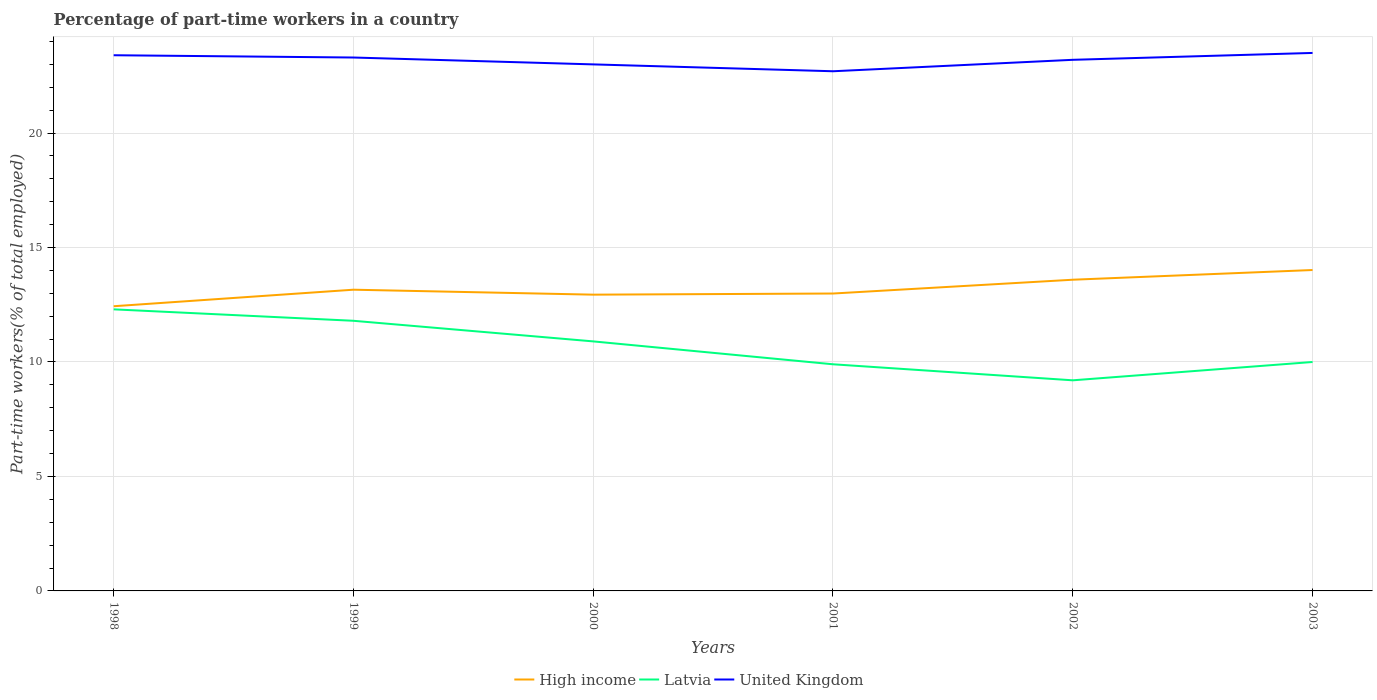Does the line corresponding to High income intersect with the line corresponding to United Kingdom?
Your answer should be compact. No. Is the number of lines equal to the number of legend labels?
Provide a short and direct response. Yes. Across all years, what is the maximum percentage of part-time workers in High income?
Provide a succinct answer. 12.44. In which year was the percentage of part-time workers in High income maximum?
Your answer should be very brief. 1998. What is the total percentage of part-time workers in High income in the graph?
Your answer should be compact. -0.56. What is the difference between the highest and the second highest percentage of part-time workers in High income?
Make the answer very short. 1.58. What is the difference between the highest and the lowest percentage of part-time workers in High income?
Your response must be concise. 2. Is the percentage of part-time workers in High income strictly greater than the percentage of part-time workers in United Kingdom over the years?
Your response must be concise. Yes. How many years are there in the graph?
Ensure brevity in your answer.  6. What is the difference between two consecutive major ticks on the Y-axis?
Keep it short and to the point. 5. Does the graph contain any zero values?
Your response must be concise. No. Where does the legend appear in the graph?
Offer a very short reply. Bottom center. How many legend labels are there?
Your response must be concise. 3. How are the legend labels stacked?
Make the answer very short. Horizontal. What is the title of the graph?
Offer a terse response. Percentage of part-time workers in a country. What is the label or title of the X-axis?
Provide a succinct answer. Years. What is the label or title of the Y-axis?
Ensure brevity in your answer.  Part-time workers(% of total employed). What is the Part-time workers(% of total employed) of High income in 1998?
Your answer should be compact. 12.44. What is the Part-time workers(% of total employed) of Latvia in 1998?
Provide a short and direct response. 12.3. What is the Part-time workers(% of total employed) of United Kingdom in 1998?
Your response must be concise. 23.4. What is the Part-time workers(% of total employed) in High income in 1999?
Provide a succinct answer. 13.16. What is the Part-time workers(% of total employed) in Latvia in 1999?
Your answer should be very brief. 11.8. What is the Part-time workers(% of total employed) of United Kingdom in 1999?
Provide a succinct answer. 23.3. What is the Part-time workers(% of total employed) in High income in 2000?
Your answer should be compact. 12.94. What is the Part-time workers(% of total employed) in Latvia in 2000?
Provide a succinct answer. 10.9. What is the Part-time workers(% of total employed) of United Kingdom in 2000?
Your answer should be compact. 23. What is the Part-time workers(% of total employed) of High income in 2001?
Make the answer very short. 12.99. What is the Part-time workers(% of total employed) in Latvia in 2001?
Provide a short and direct response. 9.9. What is the Part-time workers(% of total employed) of United Kingdom in 2001?
Keep it short and to the point. 22.7. What is the Part-time workers(% of total employed) in High income in 2002?
Your answer should be compact. 13.59. What is the Part-time workers(% of total employed) in Latvia in 2002?
Provide a succinct answer. 9.2. What is the Part-time workers(% of total employed) of United Kingdom in 2002?
Offer a very short reply. 23.2. What is the Part-time workers(% of total employed) of High income in 2003?
Offer a very short reply. 14.02. What is the Part-time workers(% of total employed) in United Kingdom in 2003?
Provide a short and direct response. 23.5. Across all years, what is the maximum Part-time workers(% of total employed) of High income?
Ensure brevity in your answer.  14.02. Across all years, what is the maximum Part-time workers(% of total employed) in Latvia?
Ensure brevity in your answer.  12.3. Across all years, what is the maximum Part-time workers(% of total employed) of United Kingdom?
Your answer should be very brief. 23.5. Across all years, what is the minimum Part-time workers(% of total employed) of High income?
Give a very brief answer. 12.44. Across all years, what is the minimum Part-time workers(% of total employed) of Latvia?
Make the answer very short. 9.2. Across all years, what is the minimum Part-time workers(% of total employed) of United Kingdom?
Your response must be concise. 22.7. What is the total Part-time workers(% of total employed) in High income in the graph?
Ensure brevity in your answer.  79.14. What is the total Part-time workers(% of total employed) in Latvia in the graph?
Make the answer very short. 64.1. What is the total Part-time workers(% of total employed) in United Kingdom in the graph?
Give a very brief answer. 139.1. What is the difference between the Part-time workers(% of total employed) of High income in 1998 and that in 1999?
Your response must be concise. -0.72. What is the difference between the Part-time workers(% of total employed) in Latvia in 1998 and that in 1999?
Keep it short and to the point. 0.5. What is the difference between the Part-time workers(% of total employed) in United Kingdom in 1998 and that in 1999?
Ensure brevity in your answer.  0.1. What is the difference between the Part-time workers(% of total employed) in High income in 1998 and that in 2000?
Make the answer very short. -0.51. What is the difference between the Part-time workers(% of total employed) in High income in 1998 and that in 2001?
Make the answer very short. -0.56. What is the difference between the Part-time workers(% of total employed) in United Kingdom in 1998 and that in 2001?
Provide a short and direct response. 0.7. What is the difference between the Part-time workers(% of total employed) of High income in 1998 and that in 2002?
Offer a very short reply. -1.16. What is the difference between the Part-time workers(% of total employed) in United Kingdom in 1998 and that in 2002?
Your answer should be compact. 0.2. What is the difference between the Part-time workers(% of total employed) in High income in 1998 and that in 2003?
Make the answer very short. -1.58. What is the difference between the Part-time workers(% of total employed) in Latvia in 1998 and that in 2003?
Your answer should be compact. 2.3. What is the difference between the Part-time workers(% of total employed) in High income in 1999 and that in 2000?
Ensure brevity in your answer.  0.22. What is the difference between the Part-time workers(% of total employed) in United Kingdom in 1999 and that in 2000?
Offer a terse response. 0.3. What is the difference between the Part-time workers(% of total employed) of High income in 1999 and that in 2001?
Give a very brief answer. 0.17. What is the difference between the Part-time workers(% of total employed) in Latvia in 1999 and that in 2001?
Keep it short and to the point. 1.9. What is the difference between the Part-time workers(% of total employed) in High income in 1999 and that in 2002?
Ensure brevity in your answer.  -0.44. What is the difference between the Part-time workers(% of total employed) in High income in 1999 and that in 2003?
Your response must be concise. -0.86. What is the difference between the Part-time workers(% of total employed) of Latvia in 1999 and that in 2003?
Offer a very short reply. 1.8. What is the difference between the Part-time workers(% of total employed) of High income in 2000 and that in 2001?
Make the answer very short. -0.05. What is the difference between the Part-time workers(% of total employed) of Latvia in 2000 and that in 2001?
Make the answer very short. 1. What is the difference between the Part-time workers(% of total employed) of United Kingdom in 2000 and that in 2001?
Your answer should be compact. 0.3. What is the difference between the Part-time workers(% of total employed) in High income in 2000 and that in 2002?
Your response must be concise. -0.65. What is the difference between the Part-time workers(% of total employed) in Latvia in 2000 and that in 2002?
Provide a short and direct response. 1.7. What is the difference between the Part-time workers(% of total employed) of High income in 2000 and that in 2003?
Give a very brief answer. -1.08. What is the difference between the Part-time workers(% of total employed) of United Kingdom in 2000 and that in 2003?
Your answer should be compact. -0.5. What is the difference between the Part-time workers(% of total employed) in High income in 2001 and that in 2002?
Provide a succinct answer. -0.6. What is the difference between the Part-time workers(% of total employed) in United Kingdom in 2001 and that in 2002?
Provide a short and direct response. -0.5. What is the difference between the Part-time workers(% of total employed) of High income in 2001 and that in 2003?
Offer a very short reply. -1.03. What is the difference between the Part-time workers(% of total employed) in Latvia in 2001 and that in 2003?
Your answer should be very brief. -0.1. What is the difference between the Part-time workers(% of total employed) in High income in 2002 and that in 2003?
Your answer should be very brief. -0.42. What is the difference between the Part-time workers(% of total employed) in United Kingdom in 2002 and that in 2003?
Provide a short and direct response. -0.3. What is the difference between the Part-time workers(% of total employed) in High income in 1998 and the Part-time workers(% of total employed) in Latvia in 1999?
Provide a succinct answer. 0.64. What is the difference between the Part-time workers(% of total employed) in High income in 1998 and the Part-time workers(% of total employed) in United Kingdom in 1999?
Provide a short and direct response. -10.86. What is the difference between the Part-time workers(% of total employed) of High income in 1998 and the Part-time workers(% of total employed) of Latvia in 2000?
Provide a succinct answer. 1.54. What is the difference between the Part-time workers(% of total employed) of High income in 1998 and the Part-time workers(% of total employed) of United Kingdom in 2000?
Keep it short and to the point. -10.56. What is the difference between the Part-time workers(% of total employed) in Latvia in 1998 and the Part-time workers(% of total employed) in United Kingdom in 2000?
Your answer should be compact. -10.7. What is the difference between the Part-time workers(% of total employed) in High income in 1998 and the Part-time workers(% of total employed) in Latvia in 2001?
Provide a succinct answer. 2.54. What is the difference between the Part-time workers(% of total employed) in High income in 1998 and the Part-time workers(% of total employed) in United Kingdom in 2001?
Provide a short and direct response. -10.26. What is the difference between the Part-time workers(% of total employed) of High income in 1998 and the Part-time workers(% of total employed) of Latvia in 2002?
Offer a very short reply. 3.24. What is the difference between the Part-time workers(% of total employed) in High income in 1998 and the Part-time workers(% of total employed) in United Kingdom in 2002?
Ensure brevity in your answer.  -10.76. What is the difference between the Part-time workers(% of total employed) in High income in 1998 and the Part-time workers(% of total employed) in Latvia in 2003?
Provide a short and direct response. 2.44. What is the difference between the Part-time workers(% of total employed) in High income in 1998 and the Part-time workers(% of total employed) in United Kingdom in 2003?
Offer a very short reply. -11.06. What is the difference between the Part-time workers(% of total employed) of High income in 1999 and the Part-time workers(% of total employed) of Latvia in 2000?
Ensure brevity in your answer.  2.26. What is the difference between the Part-time workers(% of total employed) of High income in 1999 and the Part-time workers(% of total employed) of United Kingdom in 2000?
Provide a short and direct response. -9.84. What is the difference between the Part-time workers(% of total employed) of High income in 1999 and the Part-time workers(% of total employed) of Latvia in 2001?
Offer a terse response. 3.26. What is the difference between the Part-time workers(% of total employed) of High income in 1999 and the Part-time workers(% of total employed) of United Kingdom in 2001?
Your response must be concise. -9.54. What is the difference between the Part-time workers(% of total employed) of High income in 1999 and the Part-time workers(% of total employed) of Latvia in 2002?
Provide a succinct answer. 3.96. What is the difference between the Part-time workers(% of total employed) of High income in 1999 and the Part-time workers(% of total employed) of United Kingdom in 2002?
Give a very brief answer. -10.04. What is the difference between the Part-time workers(% of total employed) of High income in 1999 and the Part-time workers(% of total employed) of Latvia in 2003?
Offer a terse response. 3.16. What is the difference between the Part-time workers(% of total employed) in High income in 1999 and the Part-time workers(% of total employed) in United Kingdom in 2003?
Keep it short and to the point. -10.34. What is the difference between the Part-time workers(% of total employed) of Latvia in 1999 and the Part-time workers(% of total employed) of United Kingdom in 2003?
Your answer should be compact. -11.7. What is the difference between the Part-time workers(% of total employed) in High income in 2000 and the Part-time workers(% of total employed) in Latvia in 2001?
Give a very brief answer. 3.04. What is the difference between the Part-time workers(% of total employed) of High income in 2000 and the Part-time workers(% of total employed) of United Kingdom in 2001?
Your answer should be compact. -9.76. What is the difference between the Part-time workers(% of total employed) in Latvia in 2000 and the Part-time workers(% of total employed) in United Kingdom in 2001?
Your answer should be very brief. -11.8. What is the difference between the Part-time workers(% of total employed) of High income in 2000 and the Part-time workers(% of total employed) of Latvia in 2002?
Your response must be concise. 3.74. What is the difference between the Part-time workers(% of total employed) of High income in 2000 and the Part-time workers(% of total employed) of United Kingdom in 2002?
Give a very brief answer. -10.26. What is the difference between the Part-time workers(% of total employed) of Latvia in 2000 and the Part-time workers(% of total employed) of United Kingdom in 2002?
Your answer should be compact. -12.3. What is the difference between the Part-time workers(% of total employed) in High income in 2000 and the Part-time workers(% of total employed) in Latvia in 2003?
Make the answer very short. 2.94. What is the difference between the Part-time workers(% of total employed) in High income in 2000 and the Part-time workers(% of total employed) in United Kingdom in 2003?
Keep it short and to the point. -10.56. What is the difference between the Part-time workers(% of total employed) of High income in 2001 and the Part-time workers(% of total employed) of Latvia in 2002?
Keep it short and to the point. 3.79. What is the difference between the Part-time workers(% of total employed) in High income in 2001 and the Part-time workers(% of total employed) in United Kingdom in 2002?
Your answer should be very brief. -10.21. What is the difference between the Part-time workers(% of total employed) in Latvia in 2001 and the Part-time workers(% of total employed) in United Kingdom in 2002?
Make the answer very short. -13.3. What is the difference between the Part-time workers(% of total employed) in High income in 2001 and the Part-time workers(% of total employed) in Latvia in 2003?
Provide a short and direct response. 2.99. What is the difference between the Part-time workers(% of total employed) in High income in 2001 and the Part-time workers(% of total employed) in United Kingdom in 2003?
Offer a very short reply. -10.51. What is the difference between the Part-time workers(% of total employed) of Latvia in 2001 and the Part-time workers(% of total employed) of United Kingdom in 2003?
Give a very brief answer. -13.6. What is the difference between the Part-time workers(% of total employed) of High income in 2002 and the Part-time workers(% of total employed) of Latvia in 2003?
Give a very brief answer. 3.59. What is the difference between the Part-time workers(% of total employed) of High income in 2002 and the Part-time workers(% of total employed) of United Kingdom in 2003?
Your answer should be compact. -9.91. What is the difference between the Part-time workers(% of total employed) of Latvia in 2002 and the Part-time workers(% of total employed) of United Kingdom in 2003?
Provide a succinct answer. -14.3. What is the average Part-time workers(% of total employed) of High income per year?
Offer a terse response. 13.19. What is the average Part-time workers(% of total employed) of Latvia per year?
Provide a succinct answer. 10.68. What is the average Part-time workers(% of total employed) of United Kingdom per year?
Your answer should be compact. 23.18. In the year 1998, what is the difference between the Part-time workers(% of total employed) of High income and Part-time workers(% of total employed) of Latvia?
Your response must be concise. 0.14. In the year 1998, what is the difference between the Part-time workers(% of total employed) in High income and Part-time workers(% of total employed) in United Kingdom?
Keep it short and to the point. -10.96. In the year 1999, what is the difference between the Part-time workers(% of total employed) of High income and Part-time workers(% of total employed) of Latvia?
Offer a terse response. 1.36. In the year 1999, what is the difference between the Part-time workers(% of total employed) in High income and Part-time workers(% of total employed) in United Kingdom?
Your response must be concise. -10.14. In the year 2000, what is the difference between the Part-time workers(% of total employed) in High income and Part-time workers(% of total employed) in Latvia?
Your answer should be very brief. 2.04. In the year 2000, what is the difference between the Part-time workers(% of total employed) in High income and Part-time workers(% of total employed) in United Kingdom?
Offer a very short reply. -10.06. In the year 2001, what is the difference between the Part-time workers(% of total employed) in High income and Part-time workers(% of total employed) in Latvia?
Provide a succinct answer. 3.09. In the year 2001, what is the difference between the Part-time workers(% of total employed) of High income and Part-time workers(% of total employed) of United Kingdom?
Your response must be concise. -9.71. In the year 2002, what is the difference between the Part-time workers(% of total employed) in High income and Part-time workers(% of total employed) in Latvia?
Make the answer very short. 4.39. In the year 2002, what is the difference between the Part-time workers(% of total employed) in High income and Part-time workers(% of total employed) in United Kingdom?
Your answer should be compact. -9.61. In the year 2002, what is the difference between the Part-time workers(% of total employed) in Latvia and Part-time workers(% of total employed) in United Kingdom?
Give a very brief answer. -14. In the year 2003, what is the difference between the Part-time workers(% of total employed) of High income and Part-time workers(% of total employed) of Latvia?
Your response must be concise. 4.02. In the year 2003, what is the difference between the Part-time workers(% of total employed) of High income and Part-time workers(% of total employed) of United Kingdom?
Provide a short and direct response. -9.48. What is the ratio of the Part-time workers(% of total employed) of High income in 1998 to that in 1999?
Ensure brevity in your answer.  0.95. What is the ratio of the Part-time workers(% of total employed) of Latvia in 1998 to that in 1999?
Offer a very short reply. 1.04. What is the ratio of the Part-time workers(% of total employed) of High income in 1998 to that in 2000?
Ensure brevity in your answer.  0.96. What is the ratio of the Part-time workers(% of total employed) of Latvia in 1998 to that in 2000?
Give a very brief answer. 1.13. What is the ratio of the Part-time workers(% of total employed) in United Kingdom in 1998 to that in 2000?
Make the answer very short. 1.02. What is the ratio of the Part-time workers(% of total employed) in High income in 1998 to that in 2001?
Keep it short and to the point. 0.96. What is the ratio of the Part-time workers(% of total employed) of Latvia in 1998 to that in 2001?
Provide a short and direct response. 1.24. What is the ratio of the Part-time workers(% of total employed) of United Kingdom in 1998 to that in 2001?
Your response must be concise. 1.03. What is the ratio of the Part-time workers(% of total employed) in High income in 1998 to that in 2002?
Offer a terse response. 0.91. What is the ratio of the Part-time workers(% of total employed) in Latvia in 1998 to that in 2002?
Give a very brief answer. 1.34. What is the ratio of the Part-time workers(% of total employed) in United Kingdom in 1998 to that in 2002?
Ensure brevity in your answer.  1.01. What is the ratio of the Part-time workers(% of total employed) in High income in 1998 to that in 2003?
Offer a very short reply. 0.89. What is the ratio of the Part-time workers(% of total employed) in Latvia in 1998 to that in 2003?
Keep it short and to the point. 1.23. What is the ratio of the Part-time workers(% of total employed) of United Kingdom in 1998 to that in 2003?
Make the answer very short. 1. What is the ratio of the Part-time workers(% of total employed) in High income in 1999 to that in 2000?
Keep it short and to the point. 1.02. What is the ratio of the Part-time workers(% of total employed) of Latvia in 1999 to that in 2000?
Offer a very short reply. 1.08. What is the ratio of the Part-time workers(% of total employed) in High income in 1999 to that in 2001?
Keep it short and to the point. 1.01. What is the ratio of the Part-time workers(% of total employed) of Latvia in 1999 to that in 2001?
Ensure brevity in your answer.  1.19. What is the ratio of the Part-time workers(% of total employed) of United Kingdom in 1999 to that in 2001?
Your answer should be compact. 1.03. What is the ratio of the Part-time workers(% of total employed) in High income in 1999 to that in 2002?
Offer a terse response. 0.97. What is the ratio of the Part-time workers(% of total employed) in Latvia in 1999 to that in 2002?
Provide a succinct answer. 1.28. What is the ratio of the Part-time workers(% of total employed) in High income in 1999 to that in 2003?
Offer a very short reply. 0.94. What is the ratio of the Part-time workers(% of total employed) of Latvia in 1999 to that in 2003?
Your answer should be very brief. 1.18. What is the ratio of the Part-time workers(% of total employed) of United Kingdom in 1999 to that in 2003?
Offer a very short reply. 0.99. What is the ratio of the Part-time workers(% of total employed) of Latvia in 2000 to that in 2001?
Ensure brevity in your answer.  1.1. What is the ratio of the Part-time workers(% of total employed) of United Kingdom in 2000 to that in 2001?
Your answer should be very brief. 1.01. What is the ratio of the Part-time workers(% of total employed) in Latvia in 2000 to that in 2002?
Make the answer very short. 1.18. What is the ratio of the Part-time workers(% of total employed) of High income in 2000 to that in 2003?
Give a very brief answer. 0.92. What is the ratio of the Part-time workers(% of total employed) of Latvia in 2000 to that in 2003?
Ensure brevity in your answer.  1.09. What is the ratio of the Part-time workers(% of total employed) of United Kingdom in 2000 to that in 2003?
Make the answer very short. 0.98. What is the ratio of the Part-time workers(% of total employed) of High income in 2001 to that in 2002?
Your answer should be very brief. 0.96. What is the ratio of the Part-time workers(% of total employed) in Latvia in 2001 to that in 2002?
Offer a terse response. 1.08. What is the ratio of the Part-time workers(% of total employed) of United Kingdom in 2001 to that in 2002?
Offer a terse response. 0.98. What is the ratio of the Part-time workers(% of total employed) of High income in 2001 to that in 2003?
Give a very brief answer. 0.93. What is the ratio of the Part-time workers(% of total employed) in Latvia in 2001 to that in 2003?
Your answer should be very brief. 0.99. What is the ratio of the Part-time workers(% of total employed) of High income in 2002 to that in 2003?
Your response must be concise. 0.97. What is the ratio of the Part-time workers(% of total employed) of Latvia in 2002 to that in 2003?
Make the answer very short. 0.92. What is the ratio of the Part-time workers(% of total employed) of United Kingdom in 2002 to that in 2003?
Offer a terse response. 0.99. What is the difference between the highest and the second highest Part-time workers(% of total employed) of High income?
Your response must be concise. 0.42. What is the difference between the highest and the lowest Part-time workers(% of total employed) of High income?
Keep it short and to the point. 1.58. What is the difference between the highest and the lowest Part-time workers(% of total employed) in Latvia?
Make the answer very short. 3.1. 